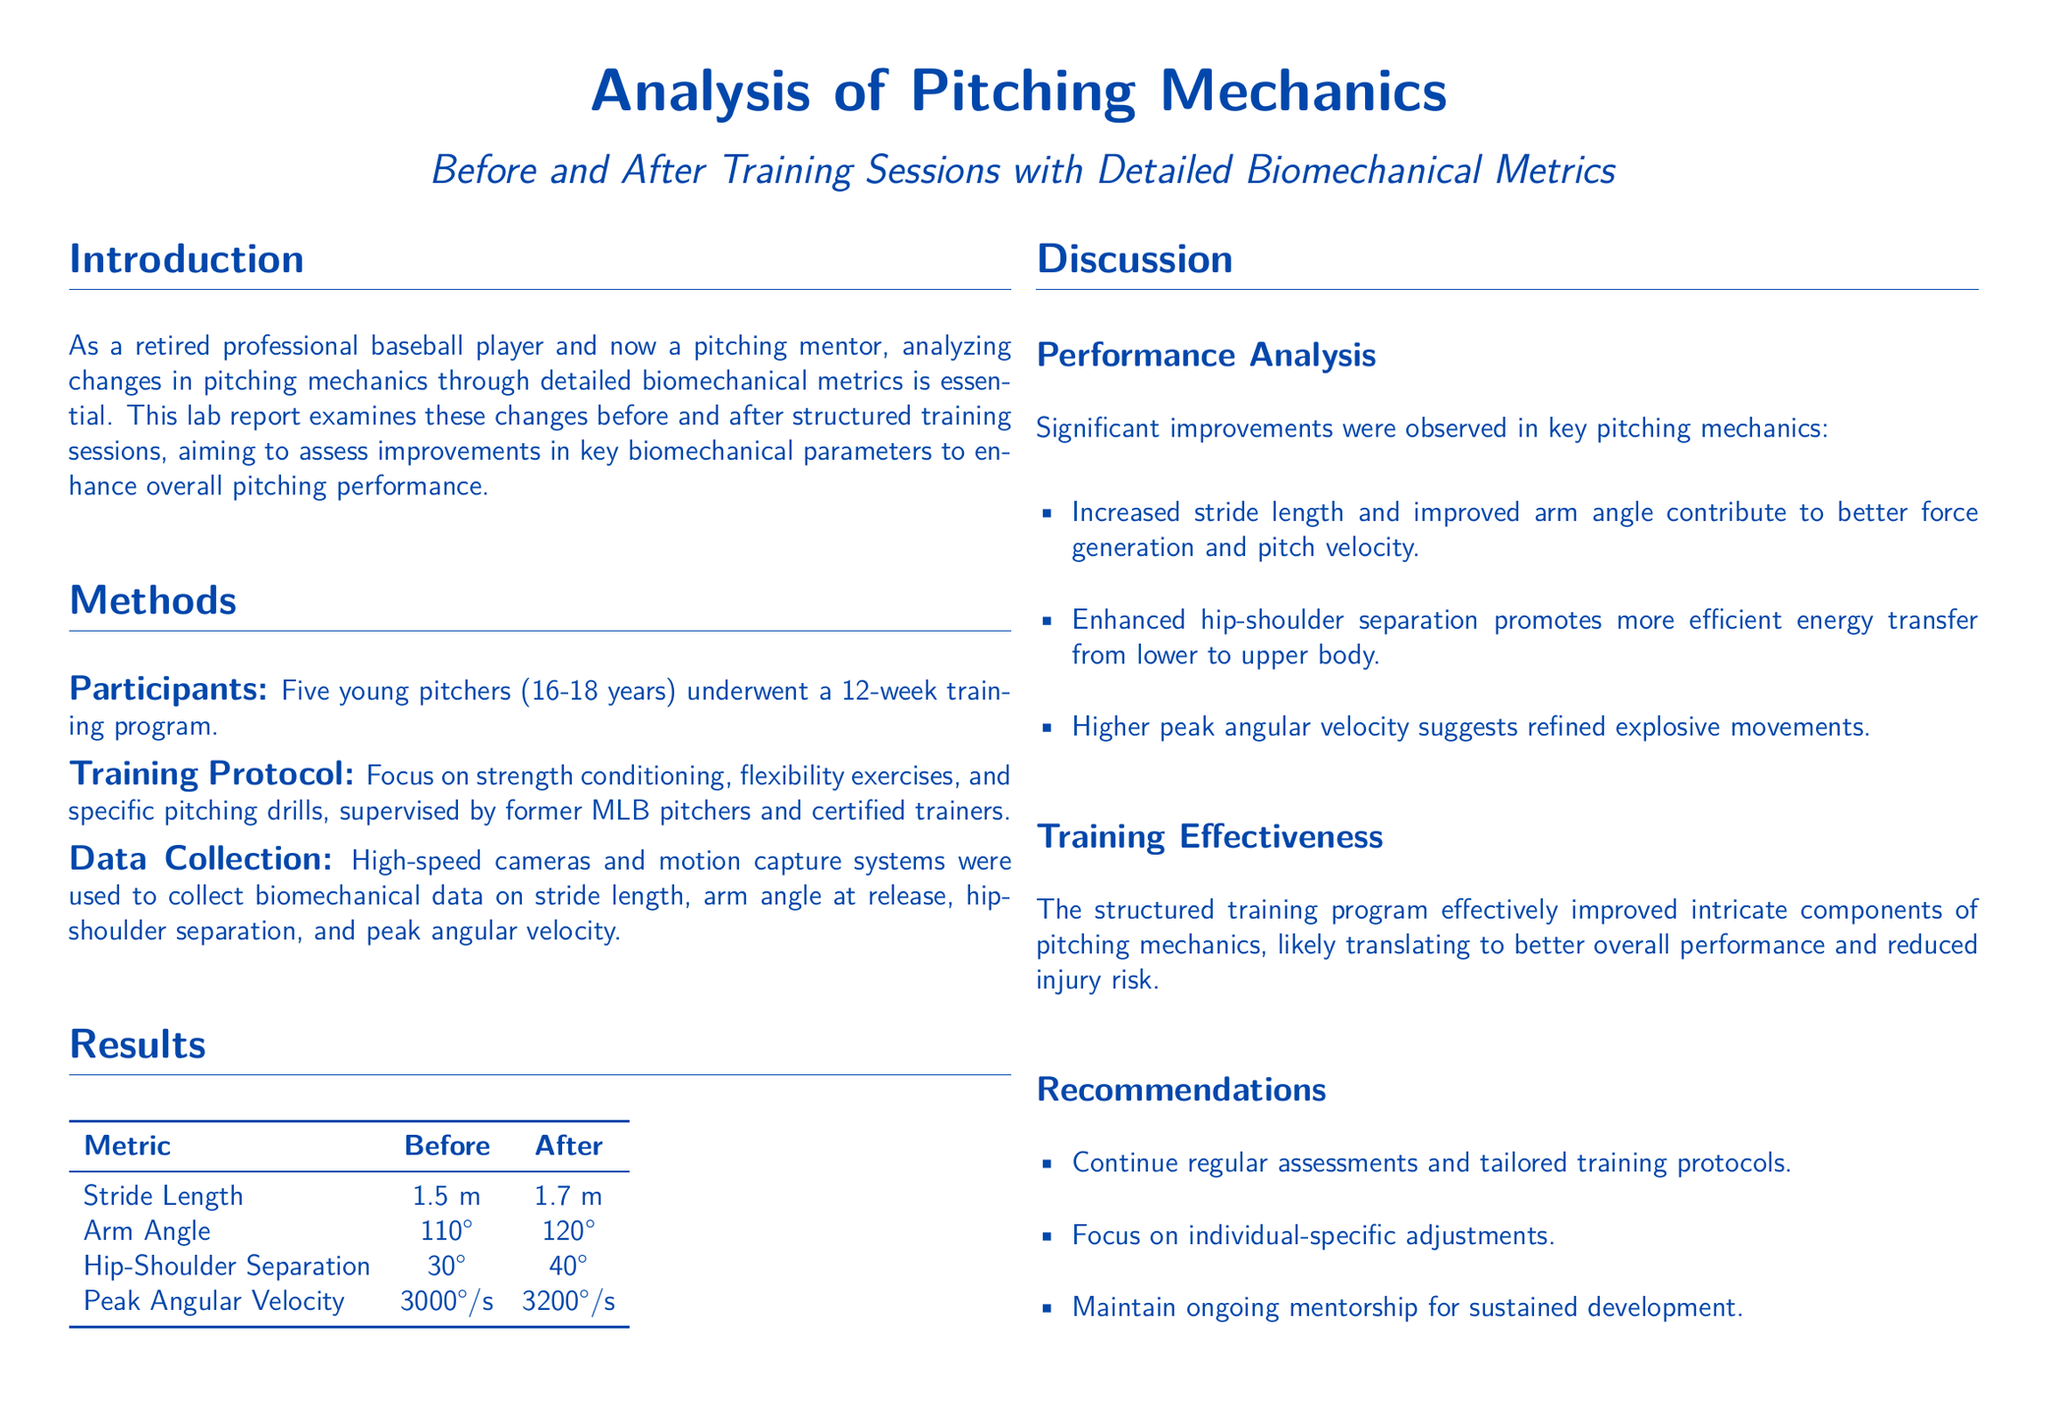What is the age range of the participants? The participants were aged between 16 and 18 years as stated in the methods section.
Answer: 16-18 years What improvement was observed in stride length? The results show movement in stride length from 1.5 m to 1.7 m after training.
Answer: 1.7 m What was the arm angle at release before training? The document indicates that the arm angle at release was 110 degrees before training.
Answer: 110 degrees How much did the hip-shoulder separation increase? The document details an increase from 30 degrees to 40 degrees, indicating the level of improvement.
Answer: 10 degrees What is the peak angular velocity after training? The results table lists the peak angular velocity after training as 3200 degrees per second.
Answer: 3200 degrees/s What type of data collection method was used? The document specifies that high-speed cameras and motion capture systems were utilized for data collection.
Answer: Motion capture systems What aspect of training was focused on during the program? The methods section highlights that strength conditioning was one aspect of the training focus.
Answer: Strength conditioning What metric showed the highest recorded value after training? The peak angular velocity metric shows the highest recorded value after training at 3200 degrees per second.
Answer: Peak Angular Velocity What is proposed for sustained development post-training? The recommendations section suggests maintaining ongoing mentorship for continued progress.
Answer: Ongoing mentorship 